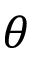<formula> <loc_0><loc_0><loc_500><loc_500>\theta</formula> 